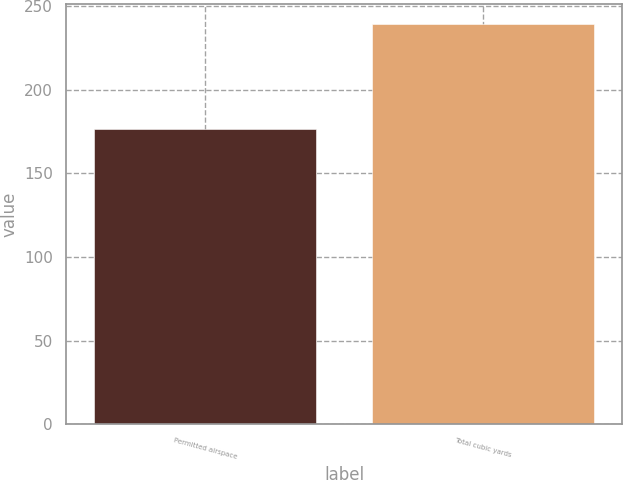Convert chart to OTSL. <chart><loc_0><loc_0><loc_500><loc_500><bar_chart><fcel>Permitted airspace<fcel>Total cubic yards<nl><fcel>176.8<fcel>239<nl></chart> 